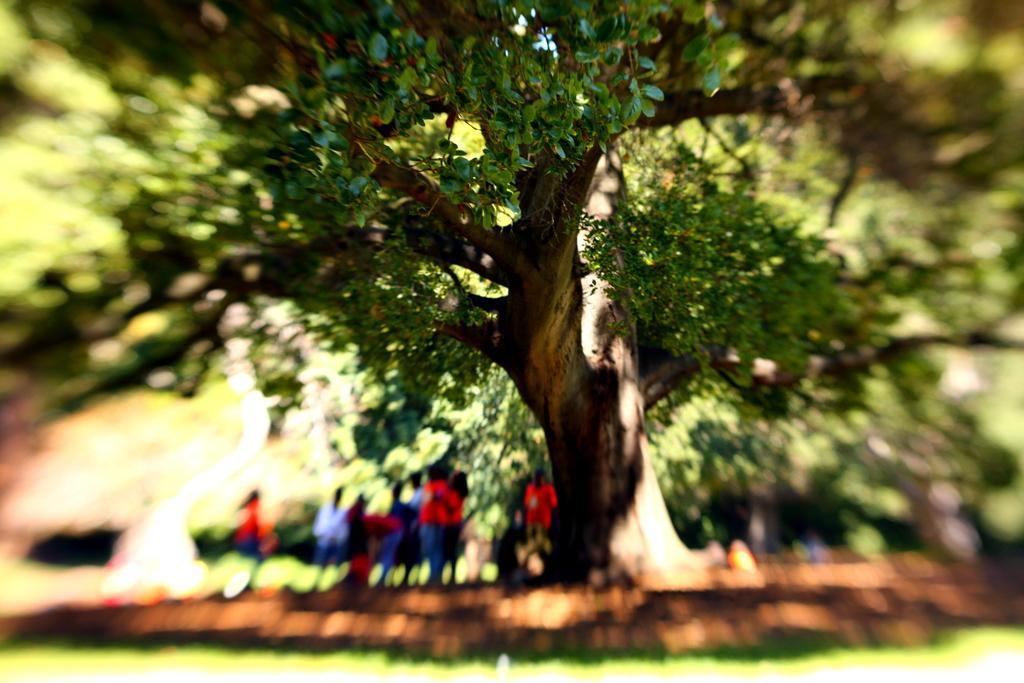Describe this image in one or two sentences. In this image we can see the trees and also the people. We can also see the grass and some part of the image is blurred. 